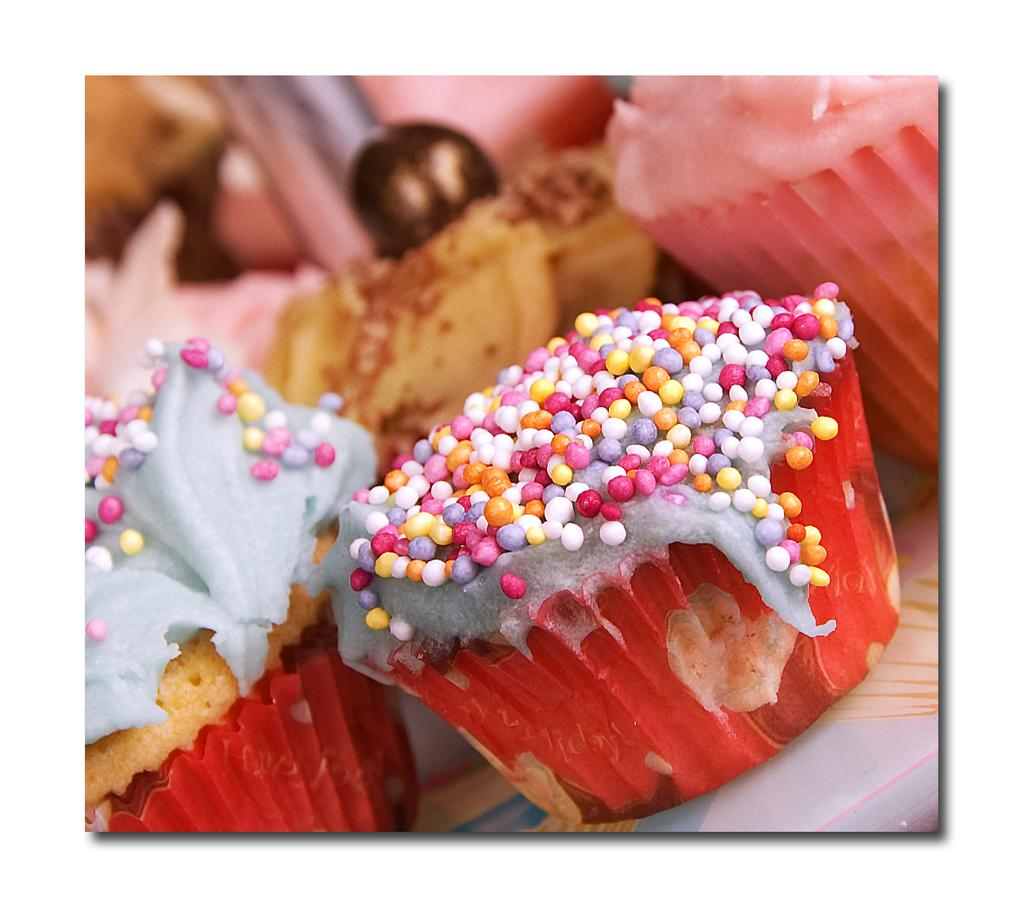What type of food can be seen in the image? There are cupcakes in the image. Where are the cupcakes located? The cupcakes are placed on a table. What decorations are on the cupcakes? There are sprinkles on the cupcakes. What type of flower is growing on the table next to the cupcakes? There is no flower present in the image; it only features cupcakes on a table. 